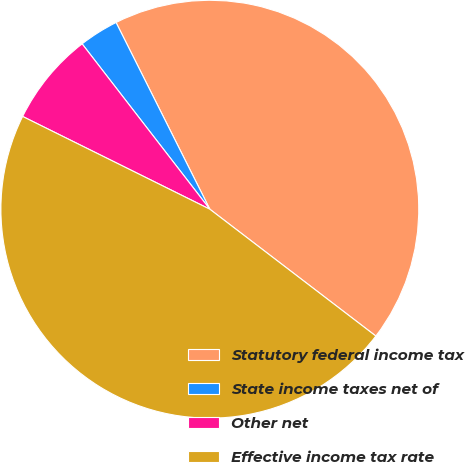<chart> <loc_0><loc_0><loc_500><loc_500><pie_chart><fcel>Statutory federal income tax<fcel>State income taxes net of<fcel>Other net<fcel>Effective income tax rate<nl><fcel>42.79%<fcel>3.06%<fcel>7.21%<fcel>46.94%<nl></chart> 